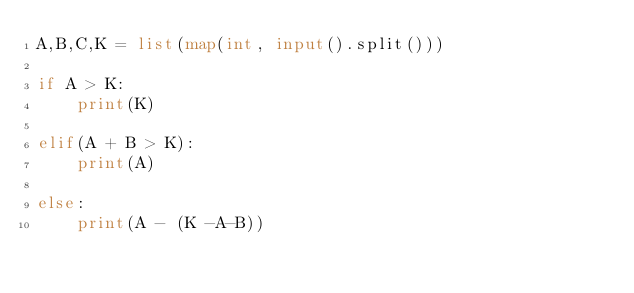Convert code to text. <code><loc_0><loc_0><loc_500><loc_500><_Python_>A,B,C,K = list(map(int, input().split()))

if A > K:
    print(K)

elif(A + B > K):
    print(A)

else:
    print(A - (K -A-B))</code> 